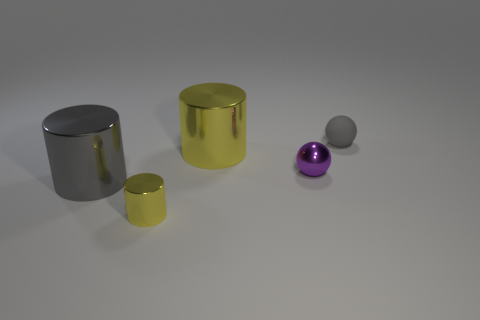Add 2 large gray metal objects. How many objects exist? 7 Subtract all spheres. How many objects are left? 3 Subtract all tiny gray balls. Subtract all gray cylinders. How many objects are left? 3 Add 5 small shiny cylinders. How many small shiny cylinders are left? 6 Add 2 gray metallic spheres. How many gray metallic spheres exist? 2 Subtract 0 blue cylinders. How many objects are left? 5 